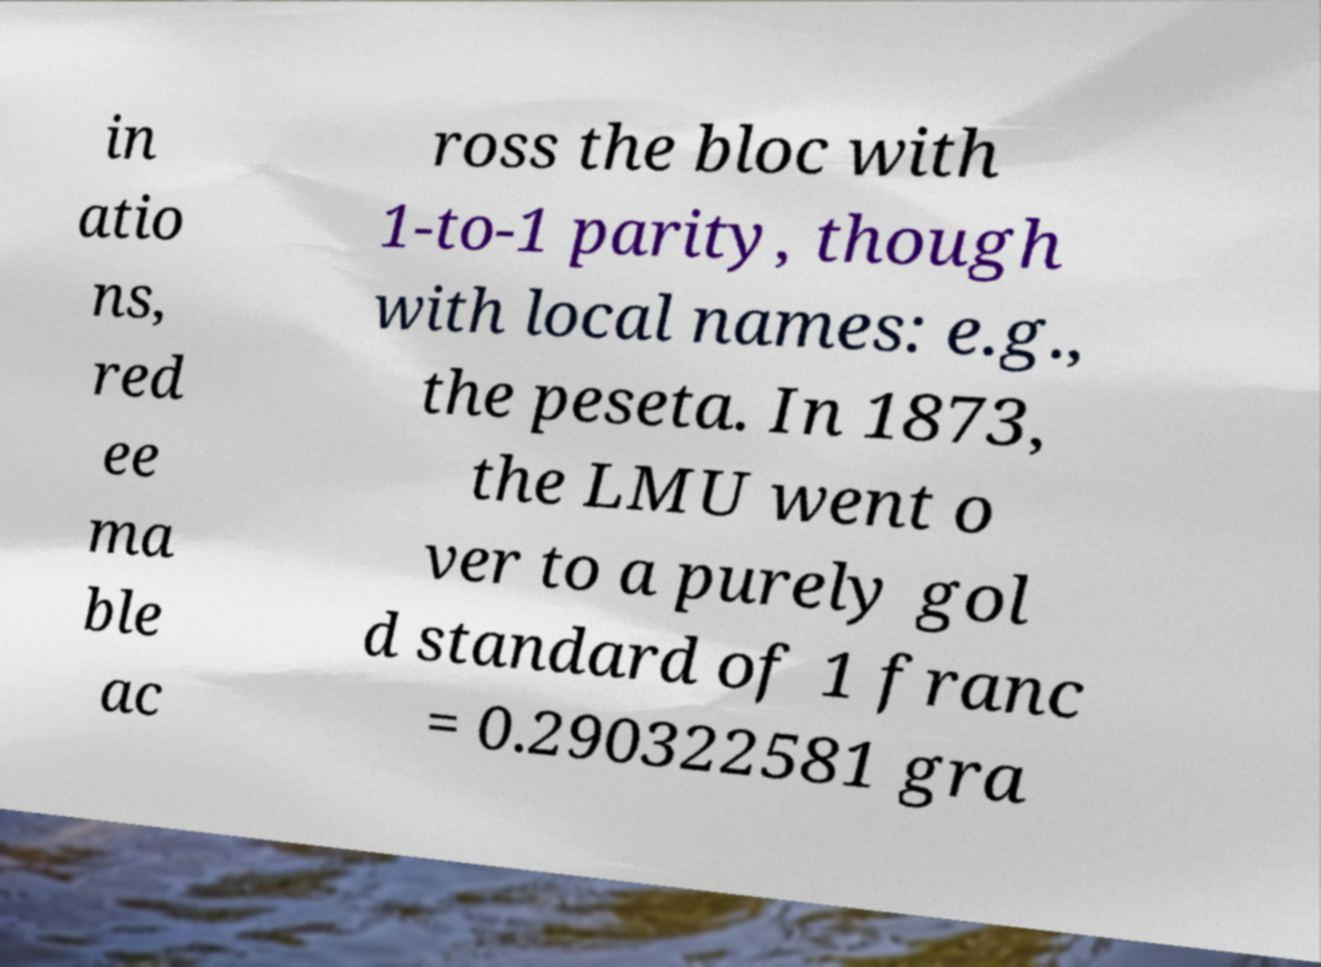Could you assist in decoding the text presented in this image and type it out clearly? in atio ns, red ee ma ble ac ross the bloc with 1-to-1 parity, though with local names: e.g., the peseta. In 1873, the LMU went o ver to a purely gol d standard of 1 franc = 0.290322581 gra 